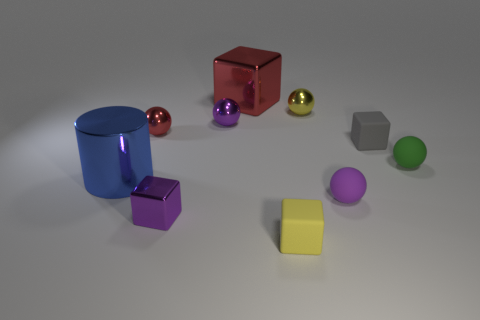If the objects were part of a learning module, what concepts could they be used to teach? These objects could serve several educational purposes. They could help teach geometry, introducing concepts like shapes (cylinders, cubes, spheres), and properties (vertices, edges, faces). In physics, they might be used to demonstrate the principles of light and reflection, as well as materials science by showing how different surfaces interact with light. 